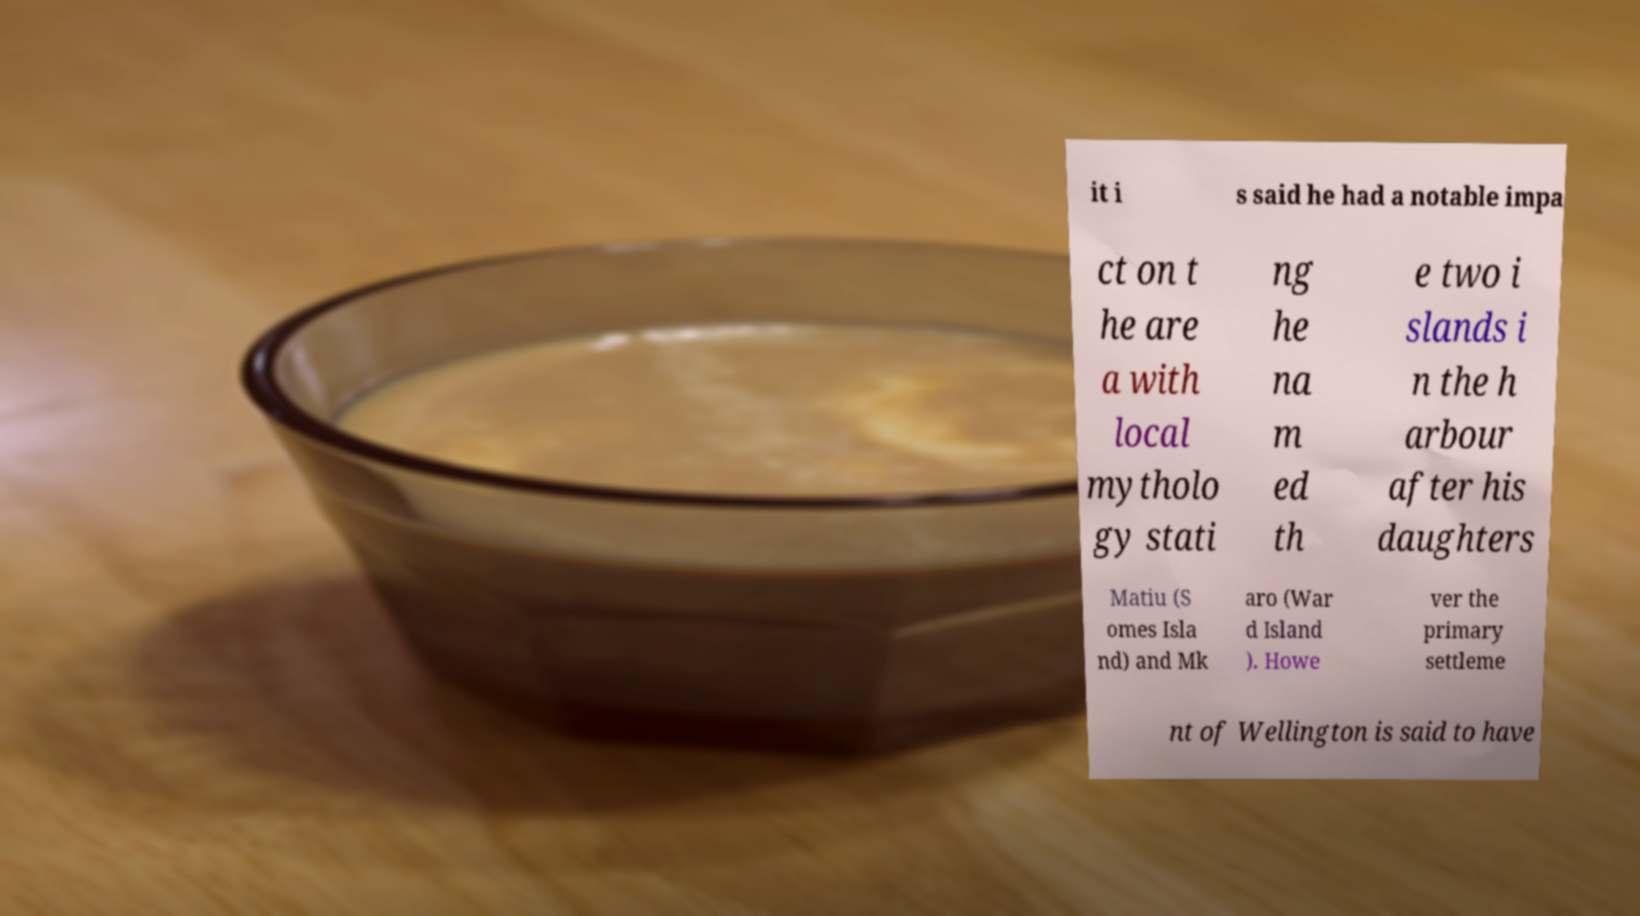For documentation purposes, I need the text within this image transcribed. Could you provide that? it i s said he had a notable impa ct on t he are a with local mytholo gy stati ng he na m ed th e two i slands i n the h arbour after his daughters Matiu (S omes Isla nd) and Mk aro (War d Island ). Howe ver the primary settleme nt of Wellington is said to have 